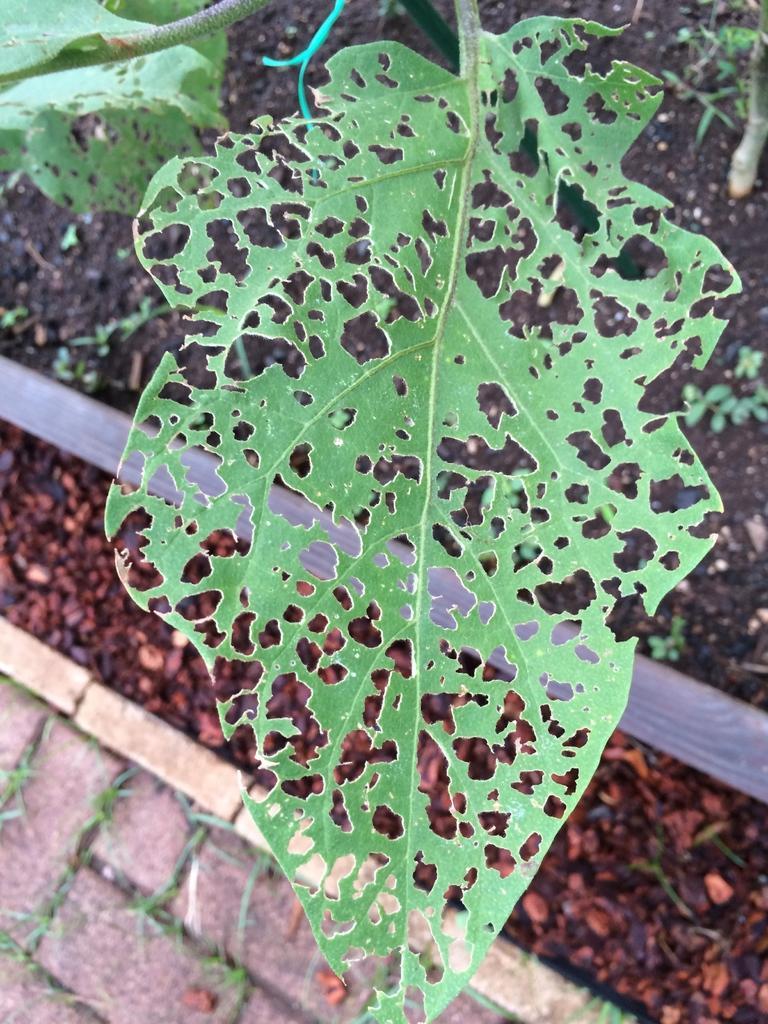How would you summarize this image in a sentence or two? This picture shows few leaves and we see small stones on the ground. 